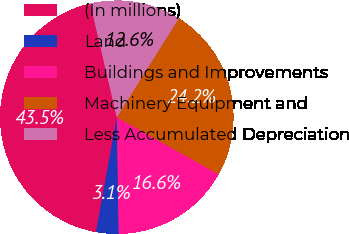Convert chart. <chart><loc_0><loc_0><loc_500><loc_500><pie_chart><fcel>(In millions)<fcel>Land<fcel>Buildings and Improvements<fcel>Machinery Equipment and<fcel>Less Accumulated Depreciation<nl><fcel>43.51%<fcel>3.11%<fcel>16.6%<fcel>24.23%<fcel>12.56%<nl></chart> 